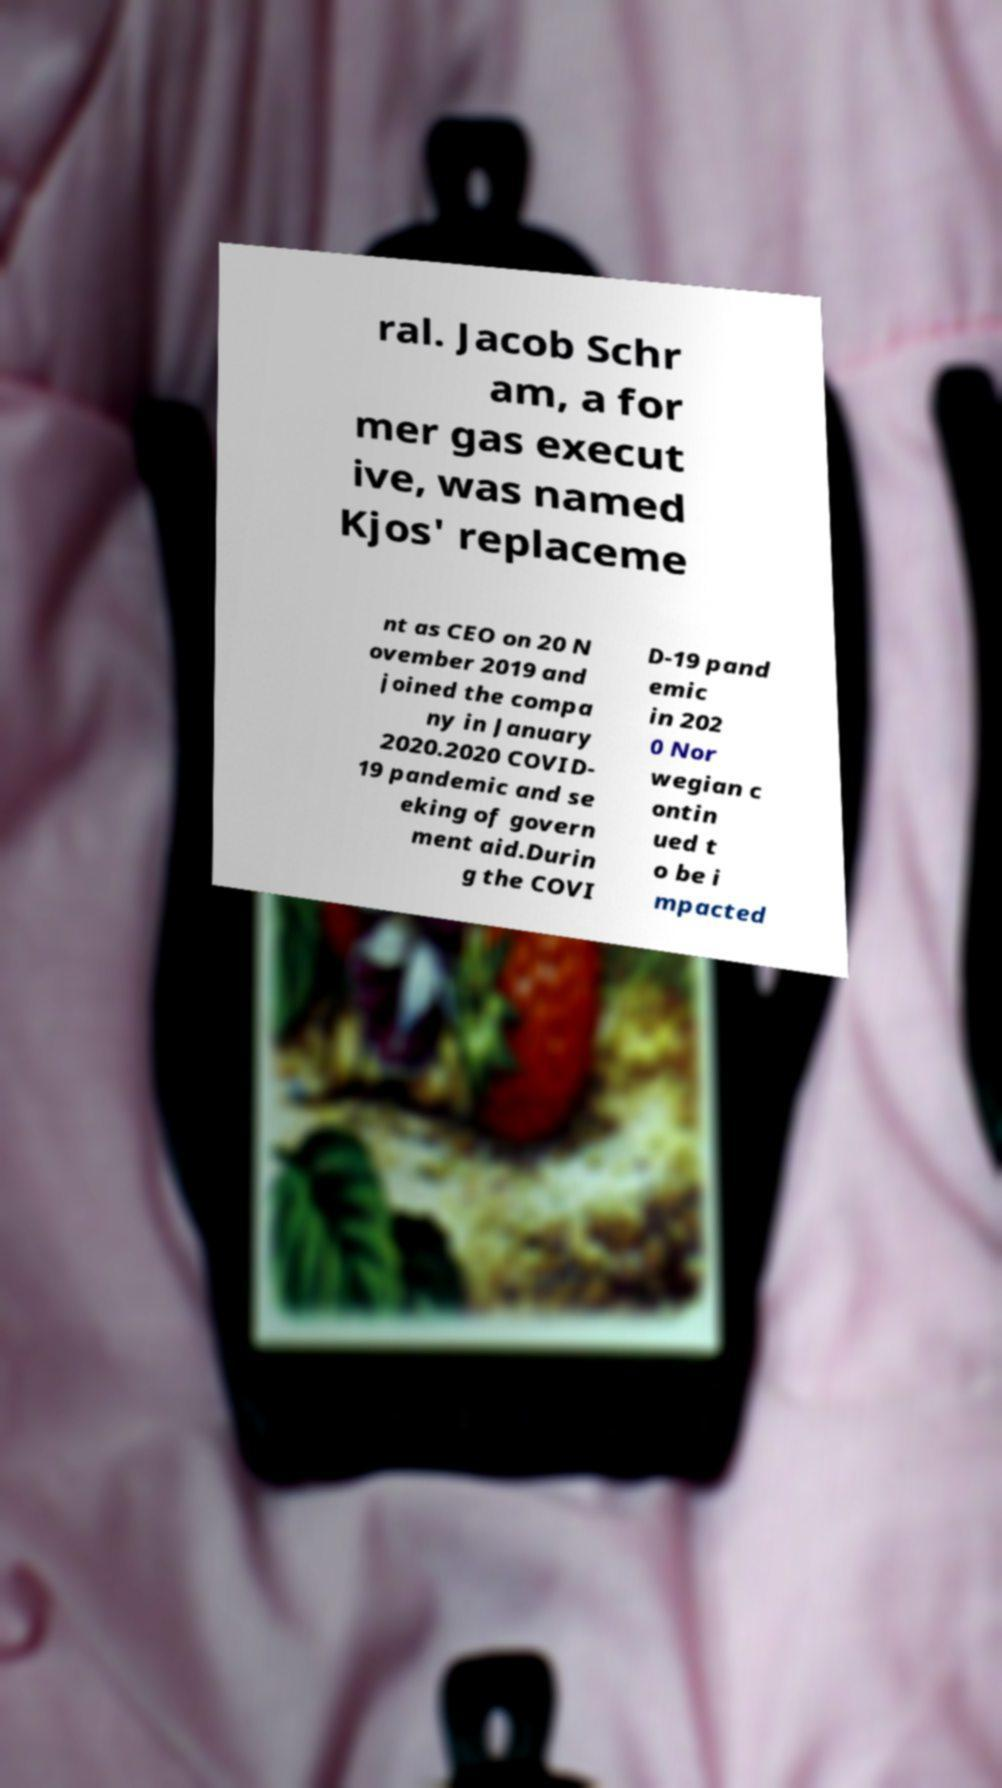Can you read and provide the text displayed in the image?This photo seems to have some interesting text. Can you extract and type it out for me? ral. Jacob Schr am, a for mer gas execut ive, was named Kjos' replaceme nt as CEO on 20 N ovember 2019 and joined the compa ny in January 2020.2020 COVID- 19 pandemic and se eking of govern ment aid.Durin g the COVI D-19 pand emic in 202 0 Nor wegian c ontin ued t o be i mpacted 